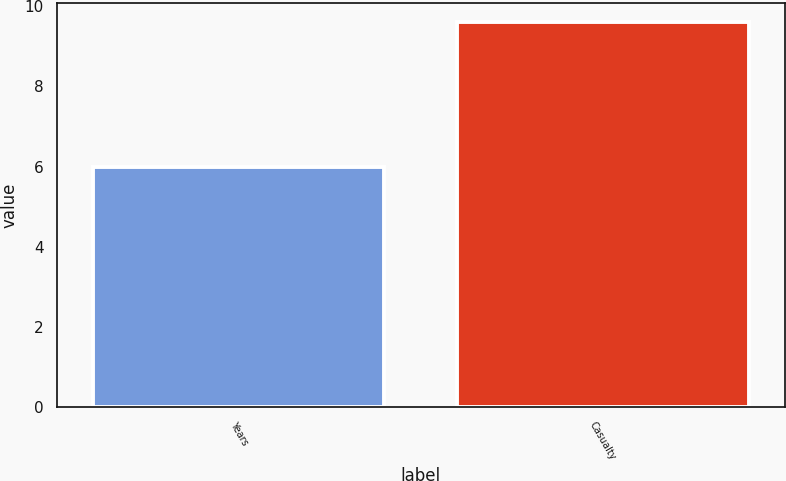Convert chart to OTSL. <chart><loc_0><loc_0><loc_500><loc_500><bar_chart><fcel>Years<fcel>Casualty<nl><fcel>6<fcel>9.6<nl></chart> 